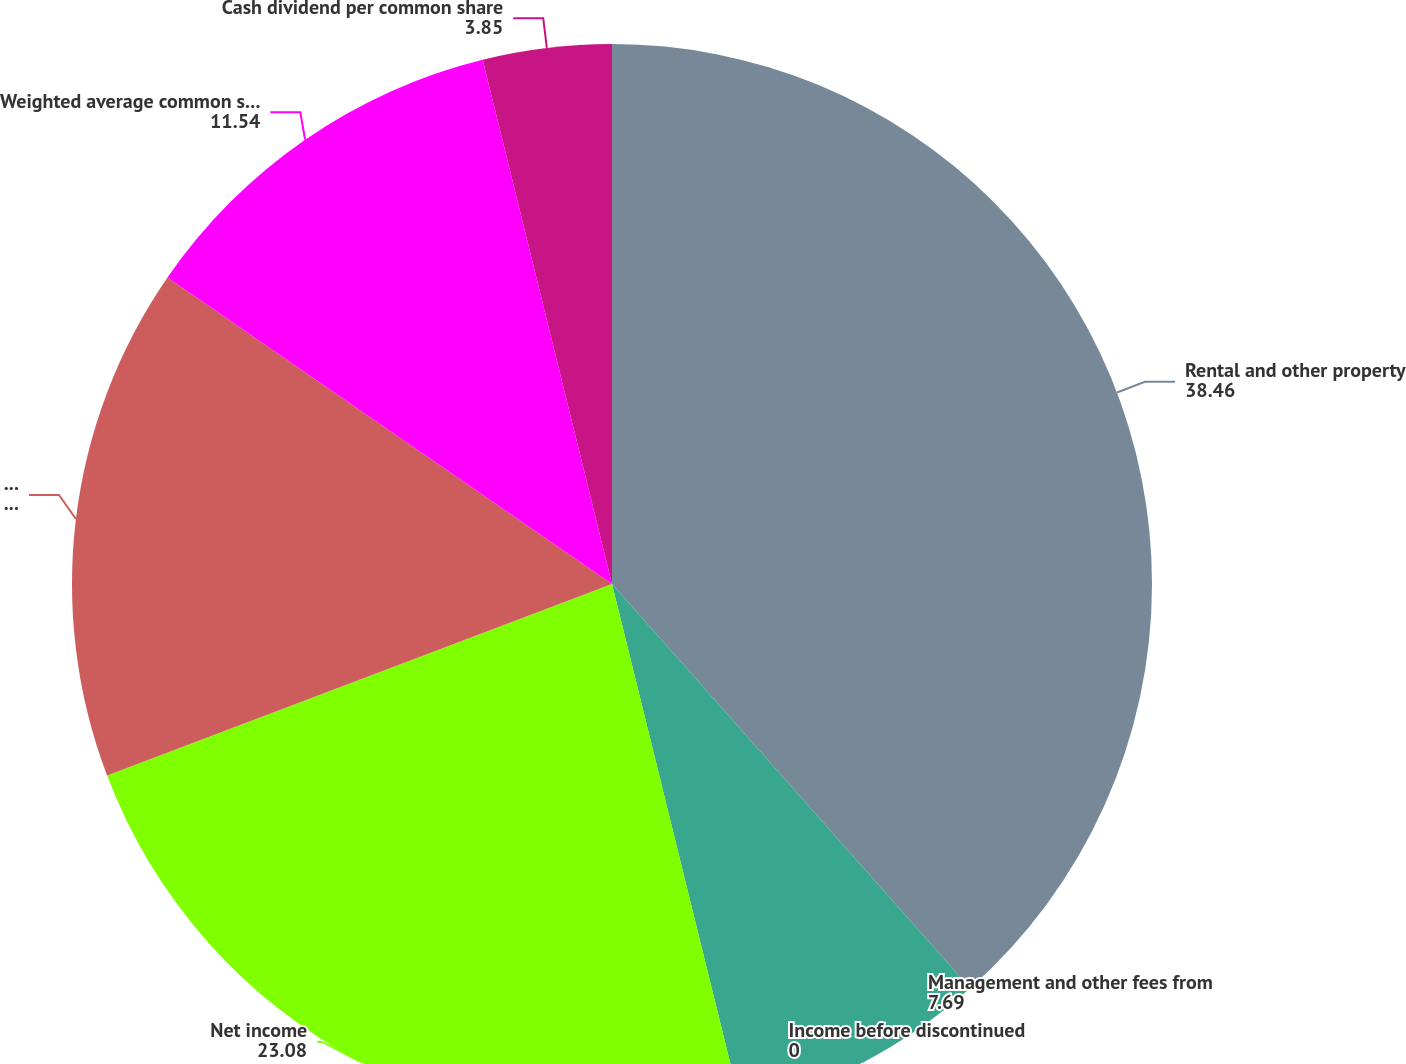Convert chart. <chart><loc_0><loc_0><loc_500><loc_500><pie_chart><fcel>Rental and other property<fcel>Management and other fees from<fcel>Income before discontinued<fcel>Net income<fcel>Net income available to common<fcel>Weighted average common stock<fcel>Cash dividend per common share<nl><fcel>38.46%<fcel>7.69%<fcel>0.0%<fcel>23.08%<fcel>15.38%<fcel>11.54%<fcel>3.85%<nl></chart> 